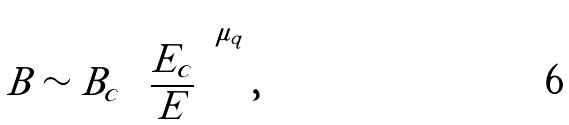<formula> <loc_0><loc_0><loc_500><loc_500>B \sim B _ { c } \left ( \frac { E _ { c } } { E } \right ) ^ { \mu _ { q } } ,</formula> 